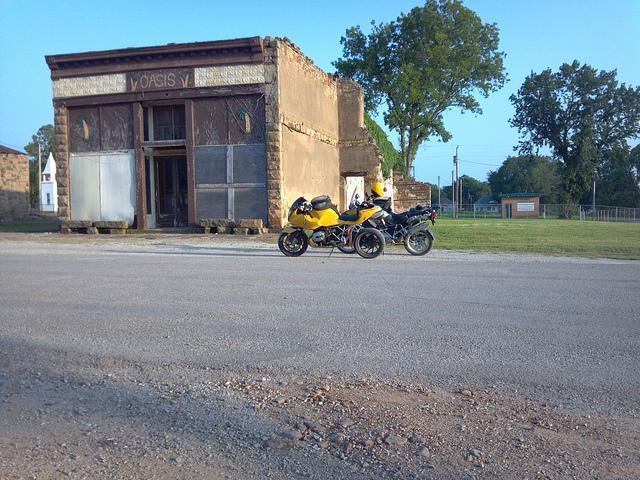How many bikes are in the photo?
Give a very brief answer. 2. How many motorcycles are in the picture?
Give a very brief answer. 2. How many people are in white?
Give a very brief answer. 0. 